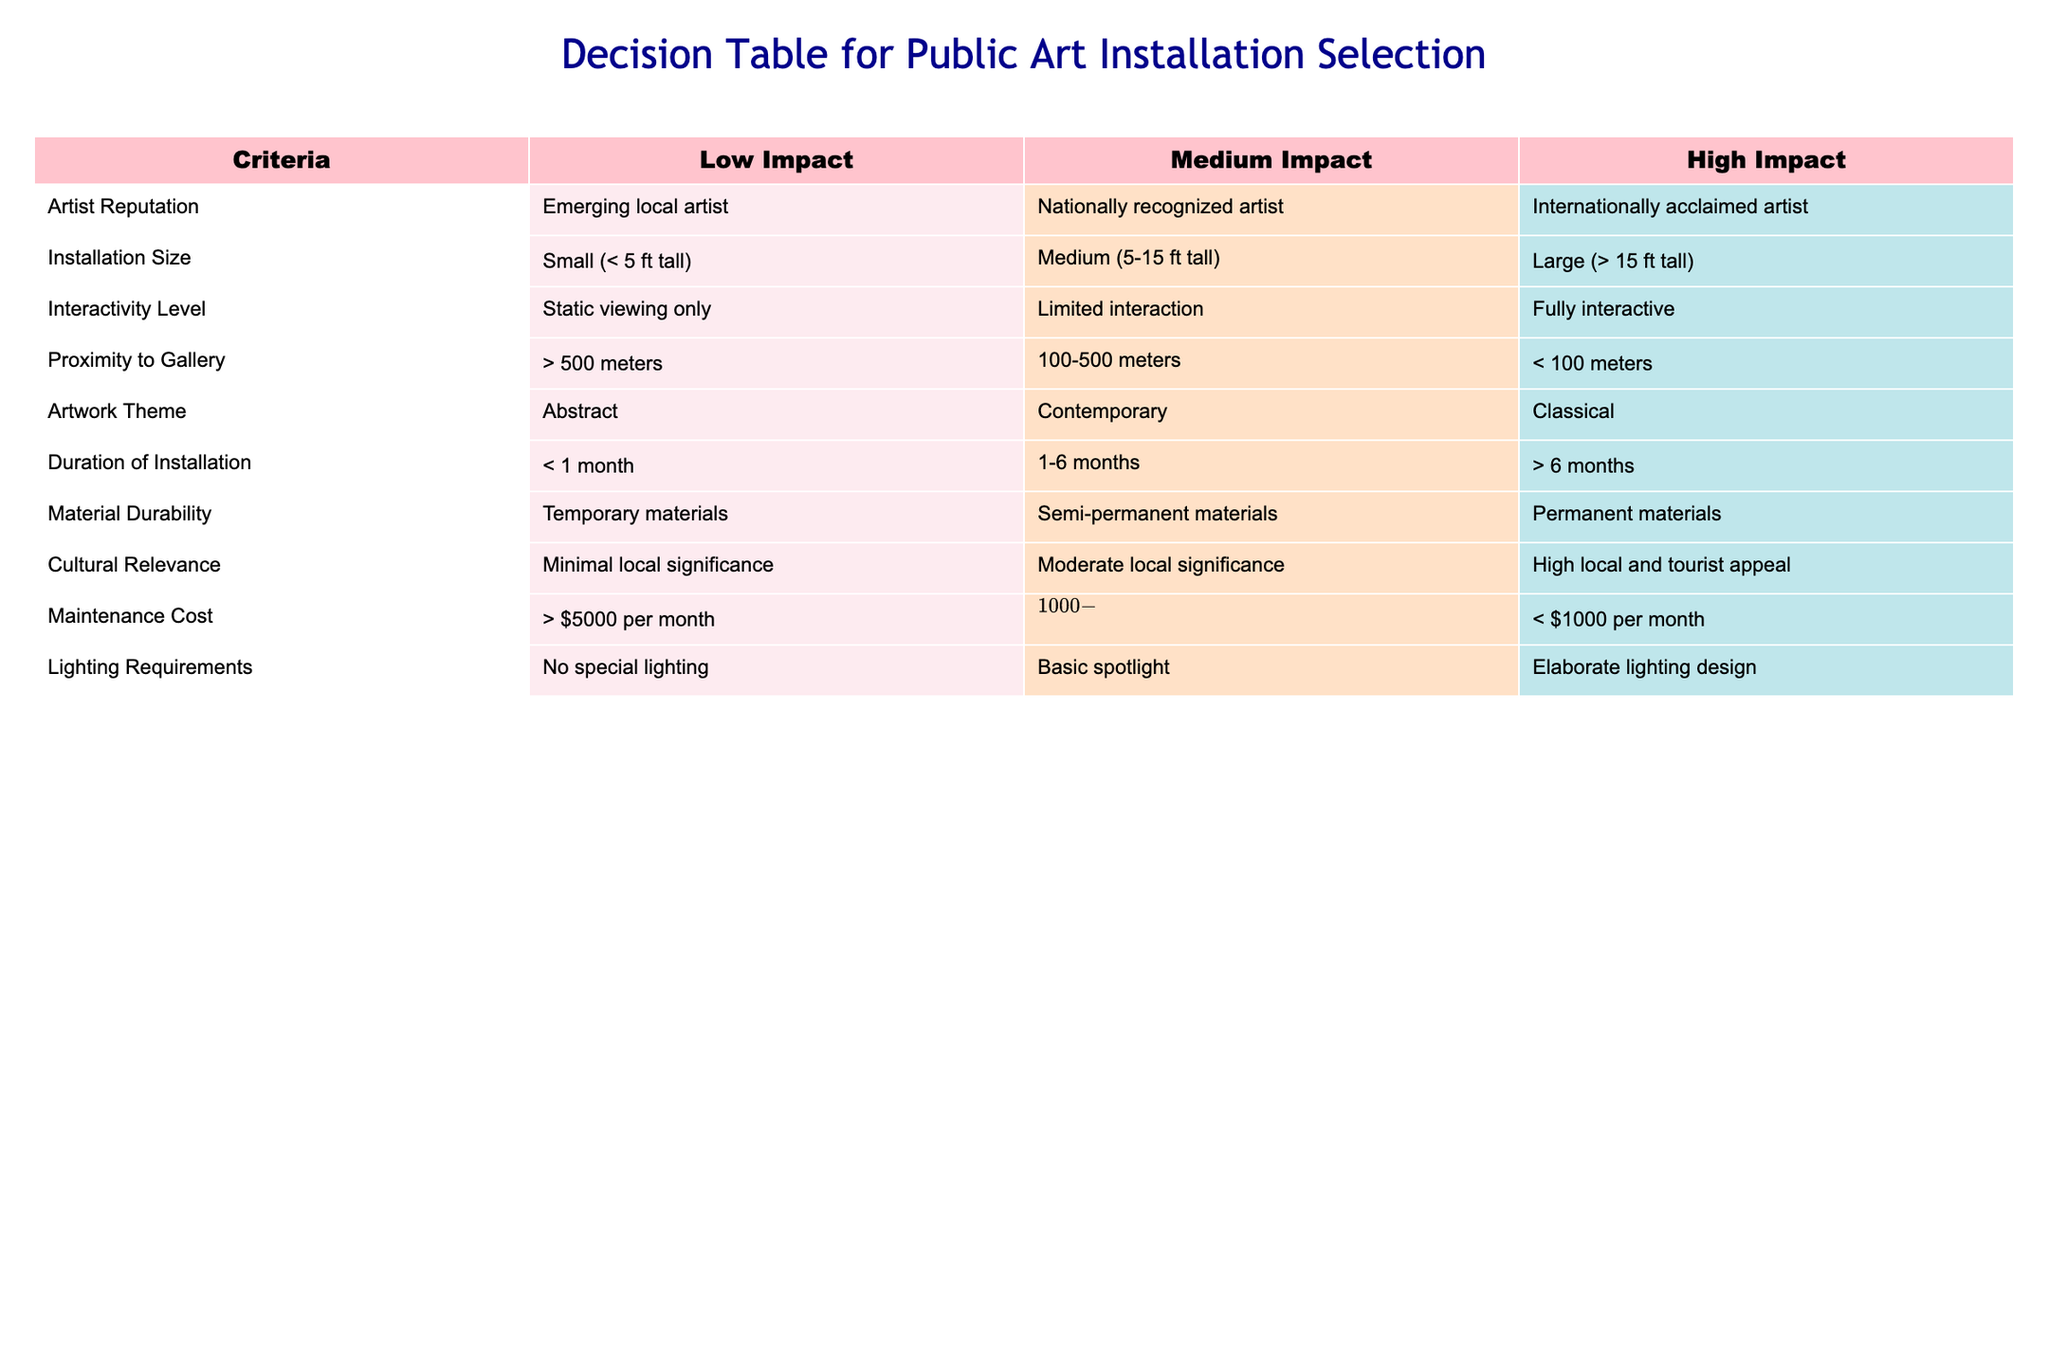What is the highest impact installation size listed in the table? The table indicates that the 'High Impact' installation size is 'Large (> 15 ft tall)', which is clearly stated under the 'Installation Size' column.
Answer: Large (> 15 ft tall) Is a nationally recognized artist considered of medium impact? Yes, the table specifies that a 'Nationally recognized artist' falls under the 'Medium Impact' category in the 'Artist Reputation' column.
Answer: Yes What is the average maintenance cost for medium impact installations? To find the average maintenance cost for medium impact installations, we take the values '$1000-$5000 per month' and assume a mid-point average between $1000 and $5000, which is $3000. Thus, the average is approximately $3000 per month.
Answer: $3000 Does a fully interactive installation require elaborate lighting design? Yes, a 'Fully interactive' installation, according to the 'Interactivity Level' row, is aligned with the 'Elaborate lighting design' requirement in the 'Lighting Requirements' column.
Answer: Yes Considering cultural relevance, what is the lowest impact option? The table indicates that for 'Cultural Relevance', the 'Low Impact' option is described as having 'Minimal local significance', which is directly stated in the table under that category.
Answer: Minimal local significance What is the relationship between installation size and impact level? Installation size increases from 'Small' for 'Low Impact', to 'Medium' for 'Medium Impact', and to 'Large' for 'High Impact', showing a direct correlation where larger installations are associated with higher impact levels.
Answer: Larger installation sizes indicate higher impact levels Can you find an example of an installation with a duration of more than six months that also has a high impact rating? Yes, under the 'Duration of Installation' category for 'High Impact', the value '> 6 months' indicates installations that last longer than six months are considered to be of high impact.
Answer: Yes What is the minimum proximity of high impact installations to the gallery? The table specifies that for 'High Impact', the proximity to the gallery is '< 100 meters', which shows that these installations are situated very close to the gallery.
Answer: < 100 meters 